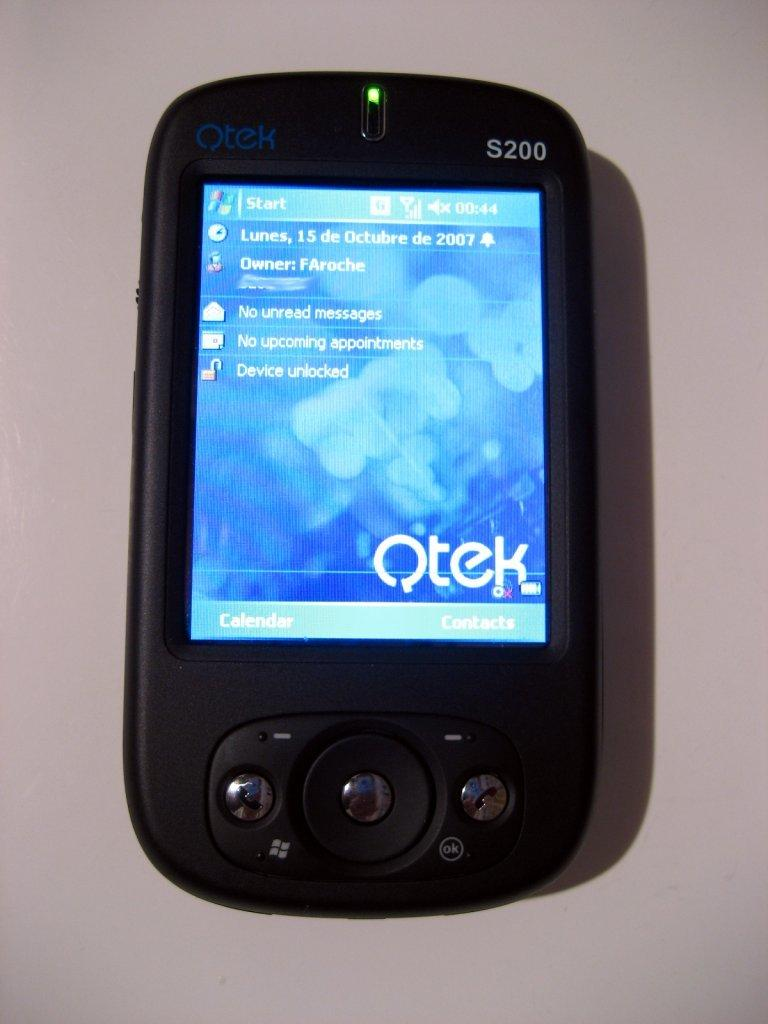<image>
Provide a brief description of the given image. A Qtek phone that displays No Unread Message, No Upcoming appointments, and that the Device is unlocked. 